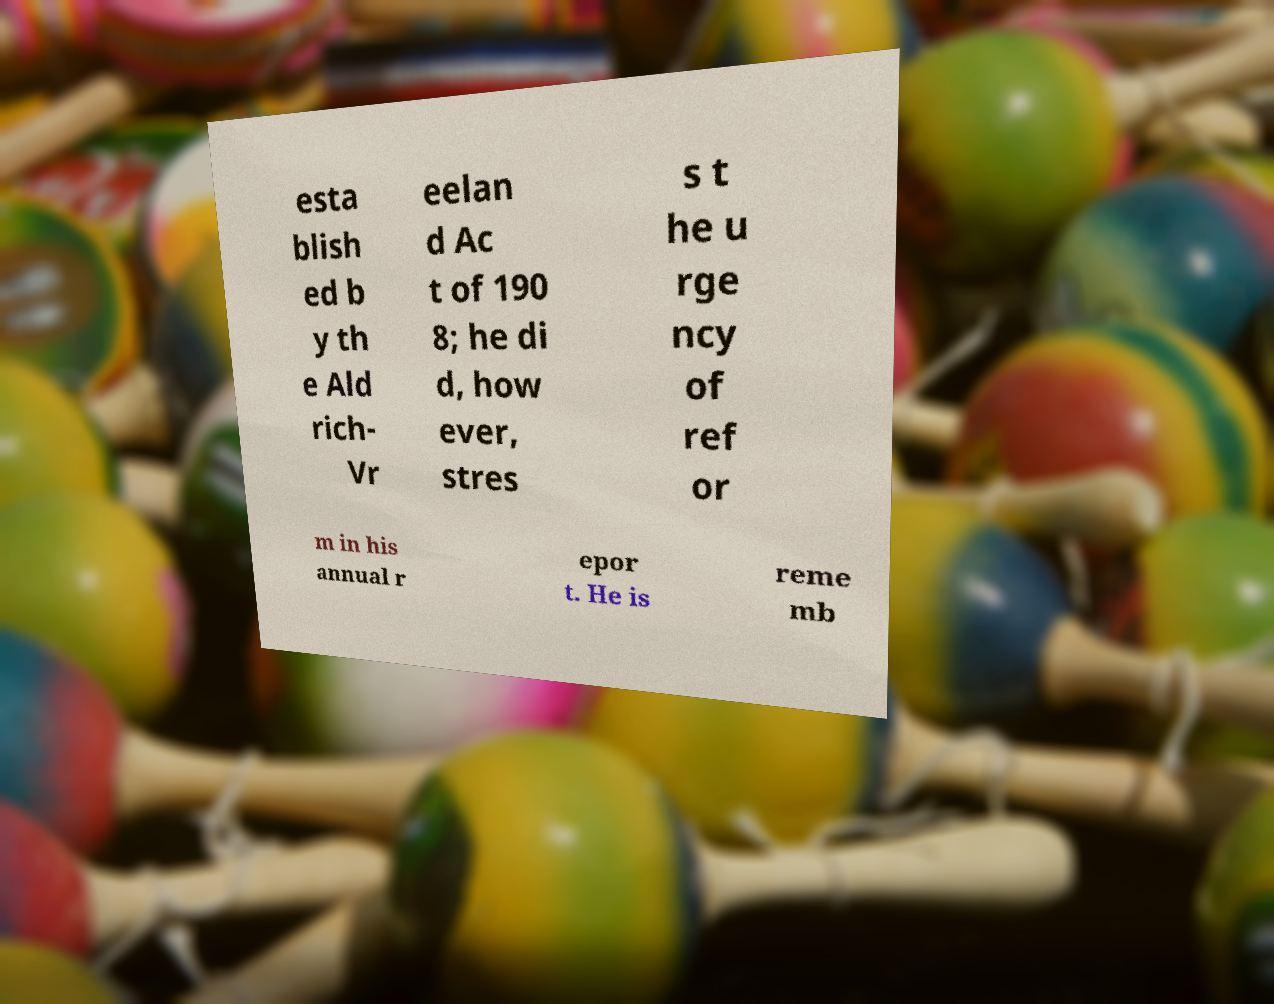Can you read and provide the text displayed in the image?This photo seems to have some interesting text. Can you extract and type it out for me? esta blish ed b y th e Ald rich- Vr eelan d Ac t of 190 8; he di d, how ever, stres s t he u rge ncy of ref or m in his annual r epor t. He is reme mb 